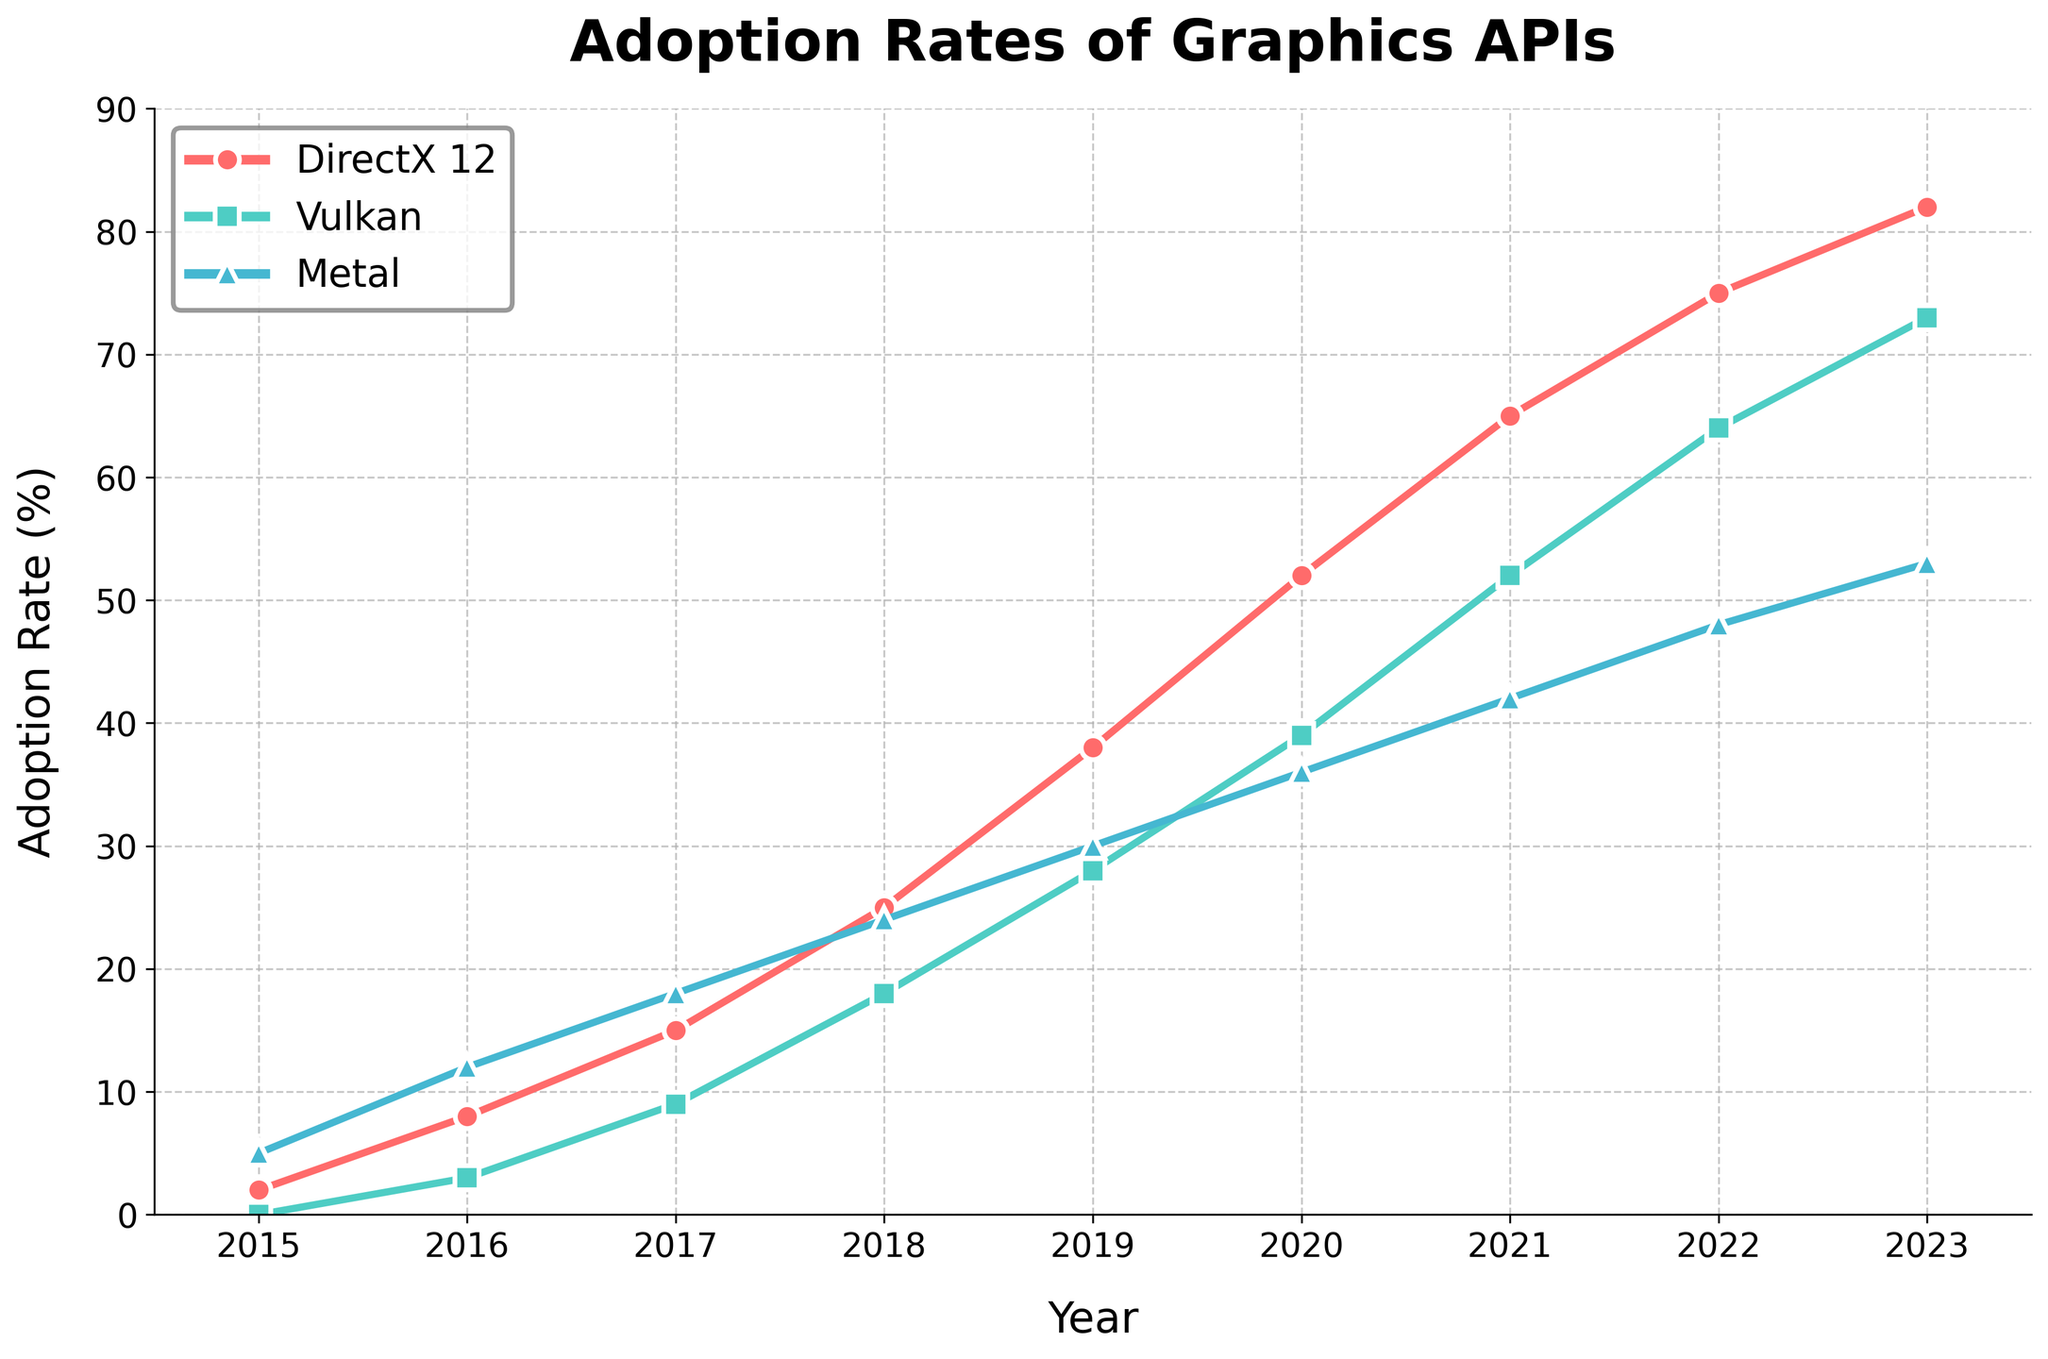What is the adoption rate of DirectX 12 in 2019? Look for the value of DirectX 12 on the vertical axis against the year 2019 on the horizontal axis. The adoption rate in 2019 is 38%.
Answer: 38% Which year did Vulkan surpass a 50% adoption rate? Check where the Vulkan line cross the 50% mark on the vertical axis and find the corresponding year on the horizontal axis. This happens in 2021.
Answer: 2021 Which API had the highest adoption rate in 2020? Compare the values of DirectX 12, Vulkan, and Metal for the year 2020. DirectX 12 has the highest rate at 52%.
Answer: DirectX 12 What is the difference in adoption rates between Vulkan and Metal in 2022? Find the adoption rates of Vulkan and Metal in 2022 and subtract the Metal rate from the Vulkan rate. Vulkan is 64% and Metal is 48%, so the difference is 64 - 48 = 16%.
Answer: 16% By how much did the adoption rate of DirectX 12 increase from 2016 to 2023? Subtract the adoption rate of DirectX 12 in 2016 from that in 2023. The values are 82% in 2023 and 8% in 2016, so the increase is 82 - 8 = 74%.
Answer: 74% In which year did Metal have a higher adoption rate than Vulkan for the last time? Identify the last year where the Metal line is above the Vulkan line before diverging permanently. This occurs in 2016.
Answer: 2016 How much did the adoption rate of Metal increase from 2015 to 2023? Subtract the adoption rate of Metal in 2015 from that in 2023. The values are 53% in 2023 and 5% in 2015, so the increase is 53 - 5 = 48%.
Answer: 48% Which year saw the highest increase in adoption rate for DirectX 12 compared to the previous year? Calculate the year-to-year differences in the adoption rate of DirectX 12 and identify the maximum increase. From 2018 to 2019, the increase is 38 - 25 = 13%.
Answer: 2019 What was the average adoption rate of Metal between 2015 and 2020? Add up the adoption rates of Metal between 2015 and 2020 and divide by the number of years. The sum is 5 + 12 + 18 + 24 + 30 + 36 = 125 and there are 6 years, so the average is 125 / 6 ≈ 20.8%.
Answer: 20.8% Which API had the slowest initial growth rate from 2015 to 2017? Look at each API's adoption rate increase between 2015 and 2017 and identify the smallest increase. Metal increased by 13%, Vulkan by 9%, and DirectX 12 by 13%. Vulkan had the slowest growth.
Answer: Vulkan 